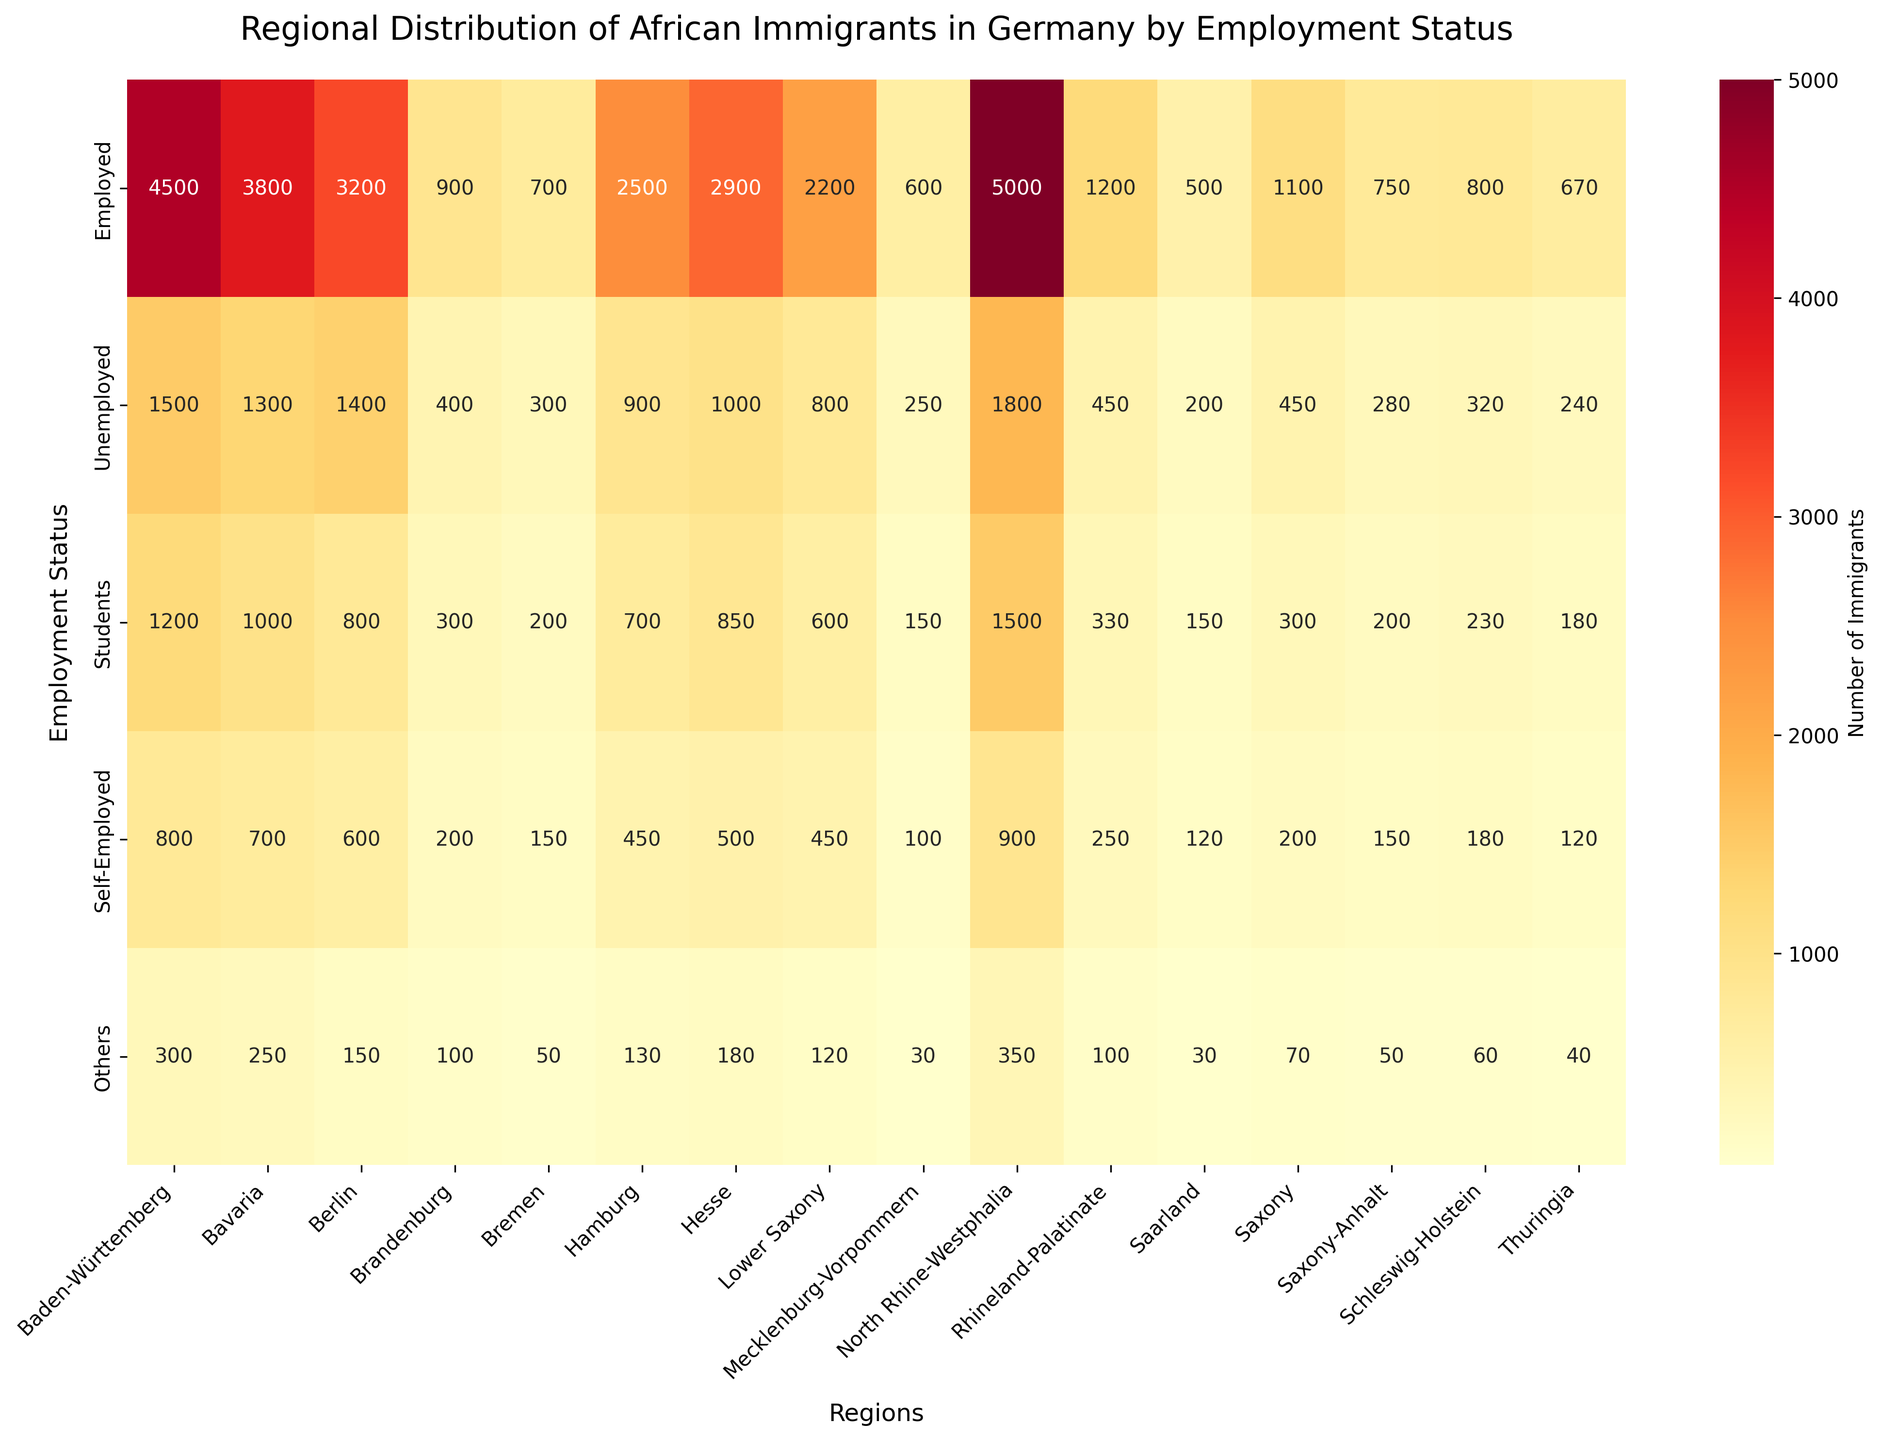What is the title of the heatmap? The title of the heatmap is displayed above the figure in a larger and bold font.
Answer: Regional Distribution of African Immigrants in Germany by Employment Status How many regions are represented in the heatmap? Count the number of different regions listed on the x-axis of the heatmap.
Answer: 16 Which region has the highest number of employed African immigrants? Look for the highest value in the 'Employed' row.
Answer: North Rhine-Westphalia What is the sum of unemployed African immigrants in Berlin and Hamburg? Add the values from the 'Unemployed' row for Berlin and Hamburg.
Answer: 2300 Which region has the least number of self-employed African immigrants? Find the smallest value in the 'Self-Employed' row.
Answer: Bremen How does the number of African students differ between Bavaria and Brandenburg? Subtract Brandenburg's number of students from Bavaria's number of students.
Answer: 700 Compare the number of 'Others' category between Hesse and Thuringia. Which region has more? Compare the number in the 'Others' row for Hesse and Thuringia to find the region with the higher value.
Answer: Hesse What is the median number of self-employed African immigrants across all regions? List the number of self-employed for all regions, sort them, and find the middle value. Values: 800, 700, 600, 500, 450, 250, 200, 150, 150, 150, 120, 100, 90, 80, 60, 50. Median is the middle value.
Answer: 150 Which employment status has the highest cumulative number of African immigrants across all regions? Sum the numbers for each employment status across all regions and compare the totals.
Answer: Employed Does Schleswig-Holstein or Saarland have a higher total number of African immigrants across all categories? Sum the numbers for all categories in Schleswig-Holstein and compare with Saarland.  Schleswig-Holstein: 800 + 320 + 230 + 180 + 60 = 1590, Saarland: 500 + 200 + 150 + 120 + 30 = 1000.
Answer: Schleswig-Holstein 